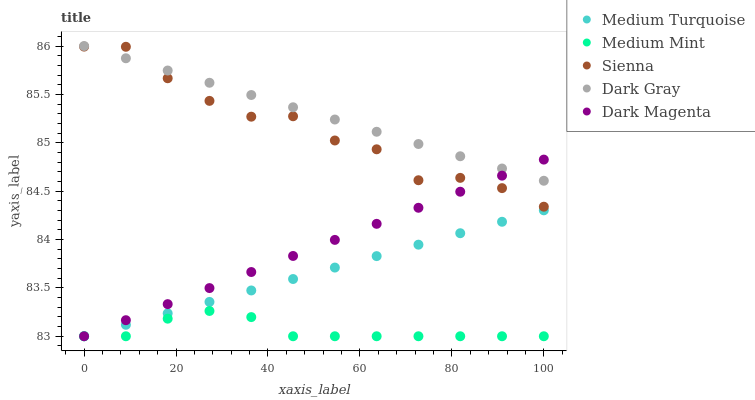Does Medium Mint have the minimum area under the curve?
Answer yes or no. Yes. Does Dark Gray have the maximum area under the curve?
Answer yes or no. Yes. Does Sienna have the minimum area under the curve?
Answer yes or no. No. Does Sienna have the maximum area under the curve?
Answer yes or no. No. Is Medium Turquoise the smoothest?
Answer yes or no. Yes. Is Sienna the roughest?
Answer yes or no. Yes. Is Dark Gray the smoothest?
Answer yes or no. No. Is Dark Gray the roughest?
Answer yes or no. No. Does Medium Mint have the lowest value?
Answer yes or no. Yes. Does Sienna have the lowest value?
Answer yes or no. No. Does Dark Gray have the highest value?
Answer yes or no. Yes. Does Sienna have the highest value?
Answer yes or no. No. Is Medium Turquoise less than Sienna?
Answer yes or no. Yes. Is Sienna greater than Medium Mint?
Answer yes or no. Yes. Does Medium Mint intersect Dark Magenta?
Answer yes or no. Yes. Is Medium Mint less than Dark Magenta?
Answer yes or no. No. Is Medium Mint greater than Dark Magenta?
Answer yes or no. No. Does Medium Turquoise intersect Sienna?
Answer yes or no. No. 